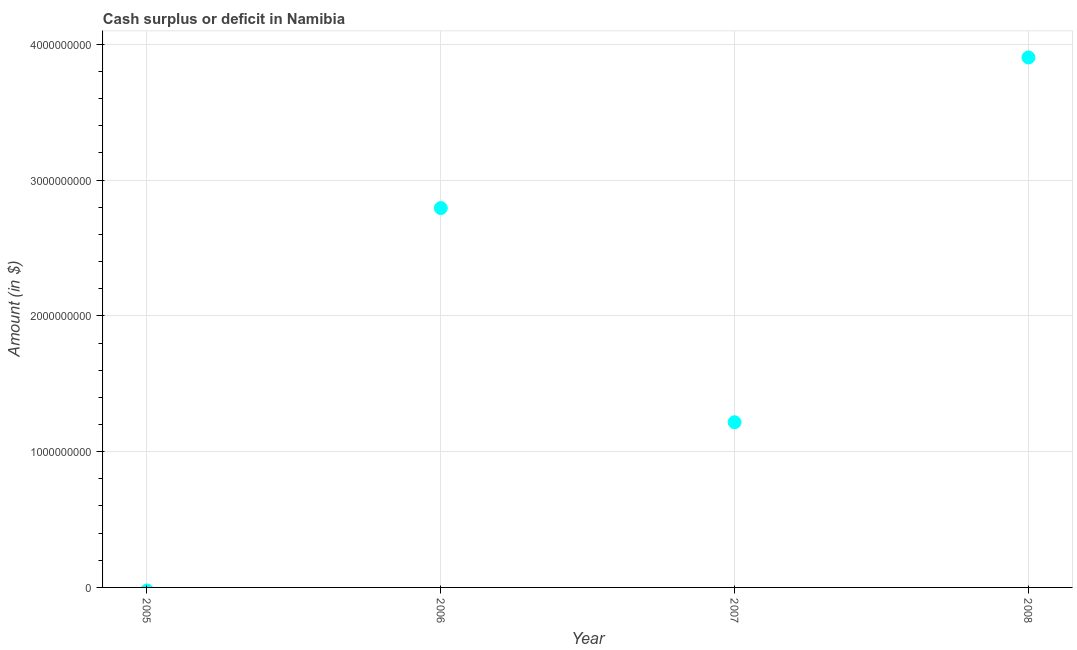What is the cash surplus or deficit in 2007?
Provide a succinct answer. 1.22e+09. Across all years, what is the maximum cash surplus or deficit?
Provide a short and direct response. 3.90e+09. In which year was the cash surplus or deficit maximum?
Your answer should be compact. 2008. What is the sum of the cash surplus or deficit?
Provide a short and direct response. 7.91e+09. What is the difference between the cash surplus or deficit in 2006 and 2007?
Your response must be concise. 1.58e+09. What is the average cash surplus or deficit per year?
Your answer should be compact. 1.98e+09. What is the median cash surplus or deficit?
Ensure brevity in your answer.  2.01e+09. In how many years, is the cash surplus or deficit greater than 1000000000 $?
Your answer should be very brief. 3. What is the ratio of the cash surplus or deficit in 2007 to that in 2008?
Provide a succinct answer. 0.31. What is the difference between the highest and the second highest cash surplus or deficit?
Offer a very short reply. 1.11e+09. What is the difference between the highest and the lowest cash surplus or deficit?
Provide a short and direct response. 3.90e+09. What is the difference between two consecutive major ticks on the Y-axis?
Provide a short and direct response. 1.00e+09. Does the graph contain grids?
Provide a short and direct response. Yes. What is the title of the graph?
Your response must be concise. Cash surplus or deficit in Namibia. What is the label or title of the Y-axis?
Your answer should be very brief. Amount (in $). What is the Amount (in $) in 2005?
Your answer should be very brief. 0. What is the Amount (in $) in 2006?
Provide a succinct answer. 2.79e+09. What is the Amount (in $) in 2007?
Your response must be concise. 1.22e+09. What is the Amount (in $) in 2008?
Give a very brief answer. 3.90e+09. What is the difference between the Amount (in $) in 2006 and 2007?
Provide a succinct answer. 1.58e+09. What is the difference between the Amount (in $) in 2006 and 2008?
Your answer should be very brief. -1.11e+09. What is the difference between the Amount (in $) in 2007 and 2008?
Provide a succinct answer. -2.69e+09. What is the ratio of the Amount (in $) in 2006 to that in 2007?
Your answer should be compact. 2.3. What is the ratio of the Amount (in $) in 2006 to that in 2008?
Provide a succinct answer. 0.72. What is the ratio of the Amount (in $) in 2007 to that in 2008?
Provide a succinct answer. 0.31. 